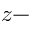Convert formula to latex. <formula><loc_0><loc_0><loc_500><loc_500>z -</formula> 